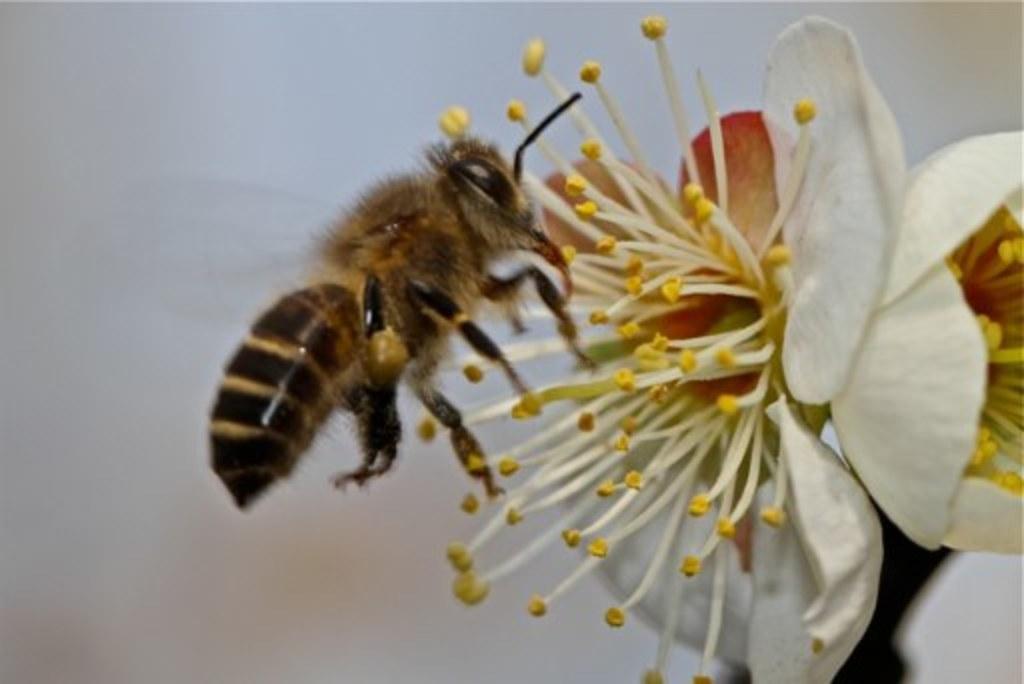Describe this image in one or two sentences. In this image I can see an insect which is cream, black and brown in color is on a flower which is cream, yellow and red in color. I can see the blurry background. 